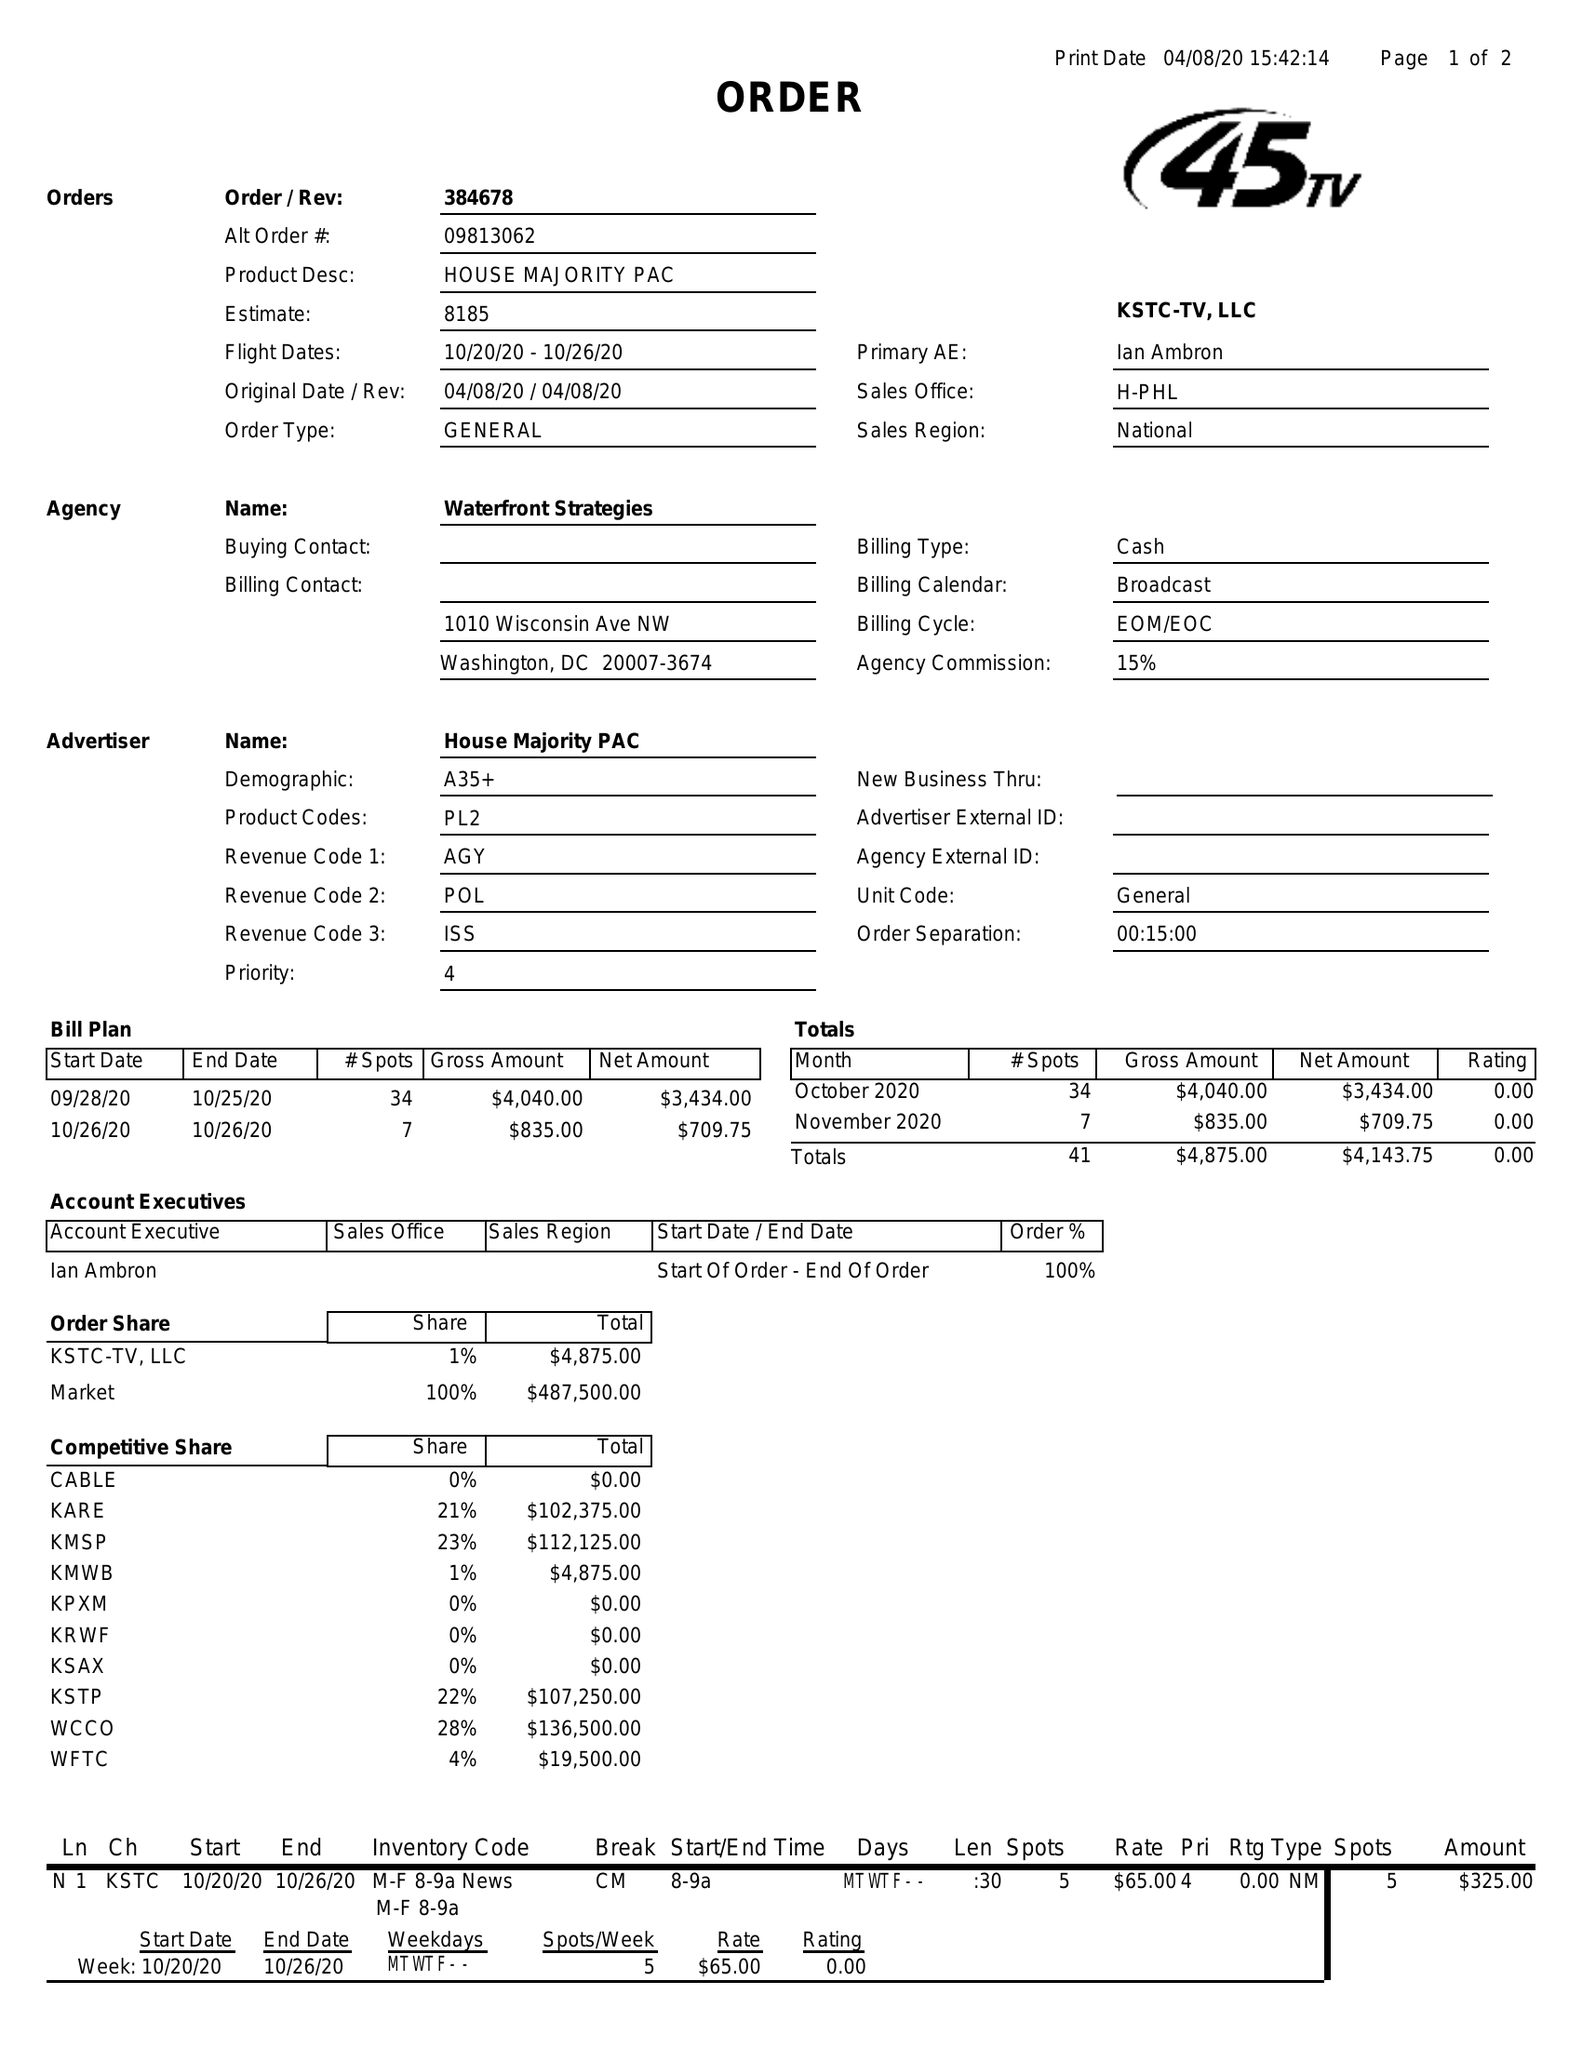What is the value for the gross_amount?
Answer the question using a single word or phrase. 4875.00 